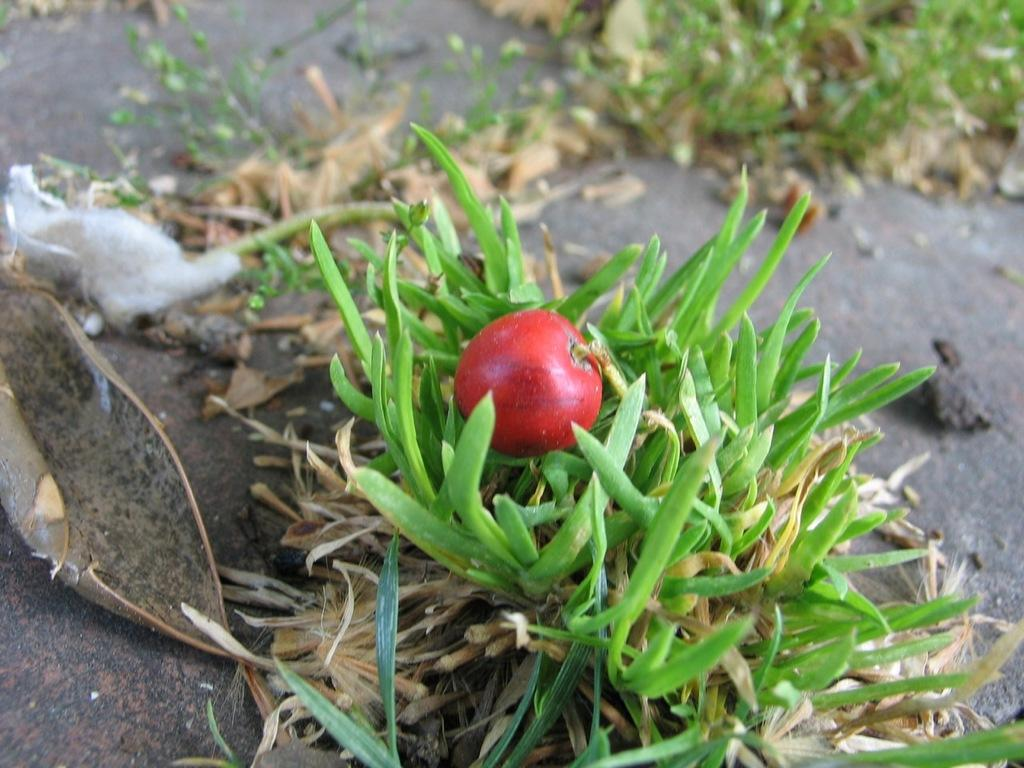What type of plant can be seen in the image? There is a plant with fruit in the image. What is on the ground in the image? There is grass on the ground in the image. What is located at the side of the image? There is a bark at the side of the image. How does the tongue of the animal in the image help it to copy the plant's fruit? There is no animal with a tongue present in the image, and the plant's fruit is not being copied by any animal. 